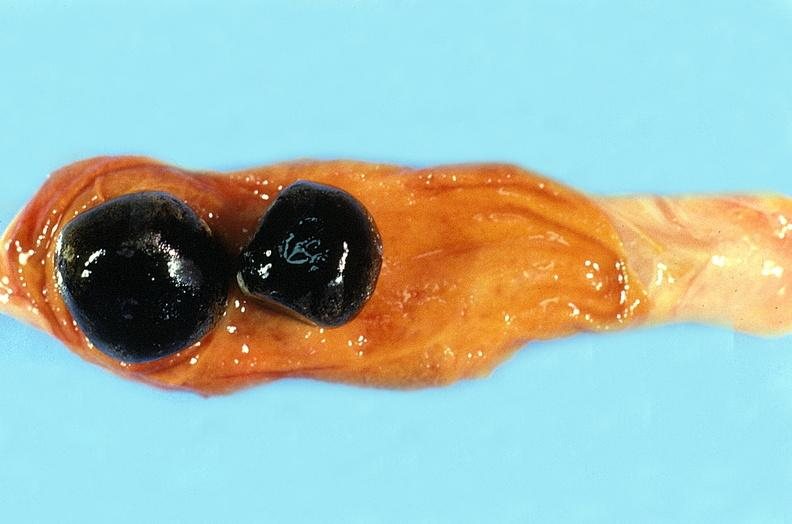where is this?
Answer the question using a single word or phrase. Urinary 